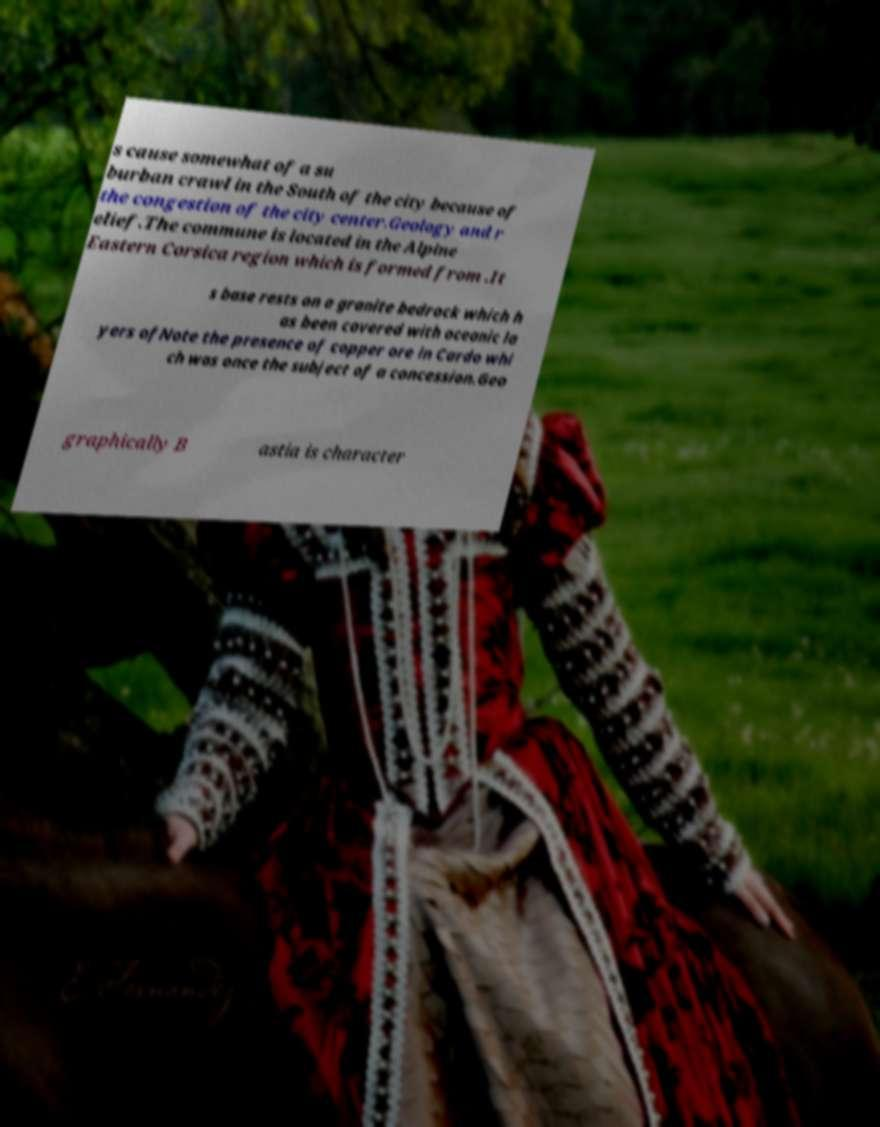Can you accurately transcribe the text from the provided image for me? s cause somewhat of a su burban crawl in the South of the city because of the congestion of the city center.Geology and r elief.The commune is located in the Alpine Eastern Corsica region which is formed from .It s base rests on a granite bedrock which h as been covered with oceanic la yers ofNote the presence of copper ore in Cardo whi ch was once the subject of a concession.Geo graphically B astia is character 